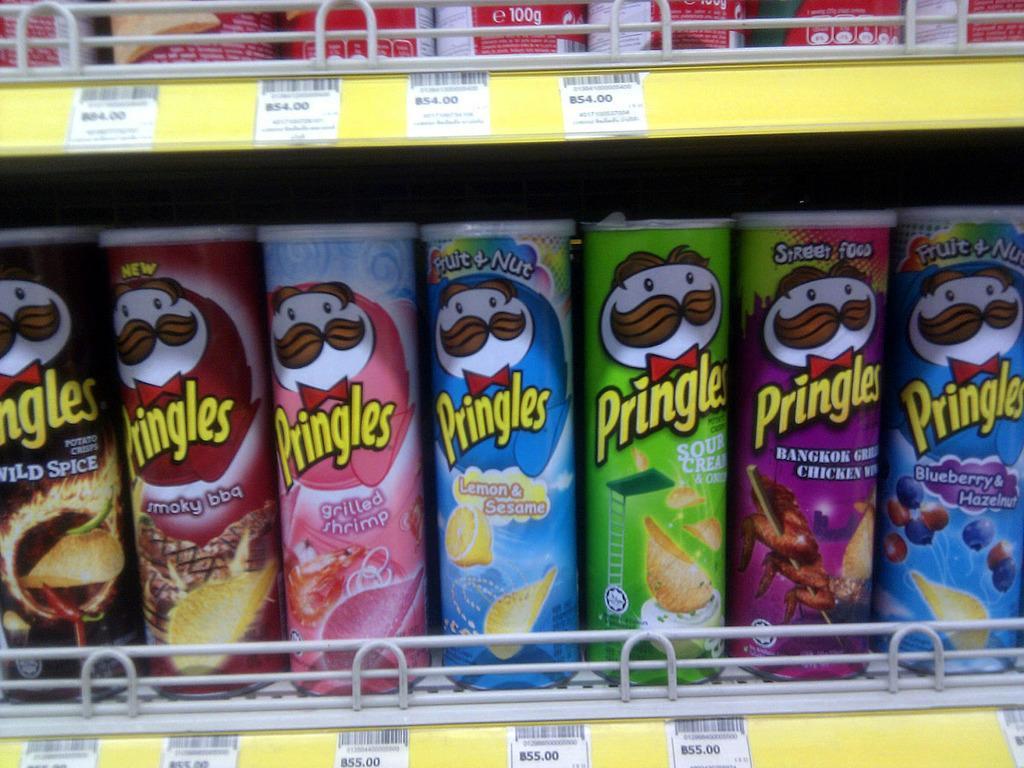Describe this image in one or two sentences. In the image there are some bottles on racks. 